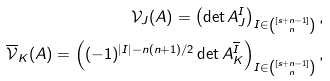Convert formula to latex. <formula><loc_0><loc_0><loc_500><loc_500>\mathcal { V } _ { J } ( A ) = \left ( \det A ^ { I } _ { J } \right ) _ { I \in \binom { [ s + n - 1 ] } { n } } , \\ \overline { \mathcal { V } } _ { K } ( A ) = \left ( ( - 1 ) ^ { | I | - n ( n + 1 ) / 2 } \det A ^ { \overline { I } } _ { K } \right ) _ { I \in \binom { [ s + n - 1 ] } { n } } ,</formula> 